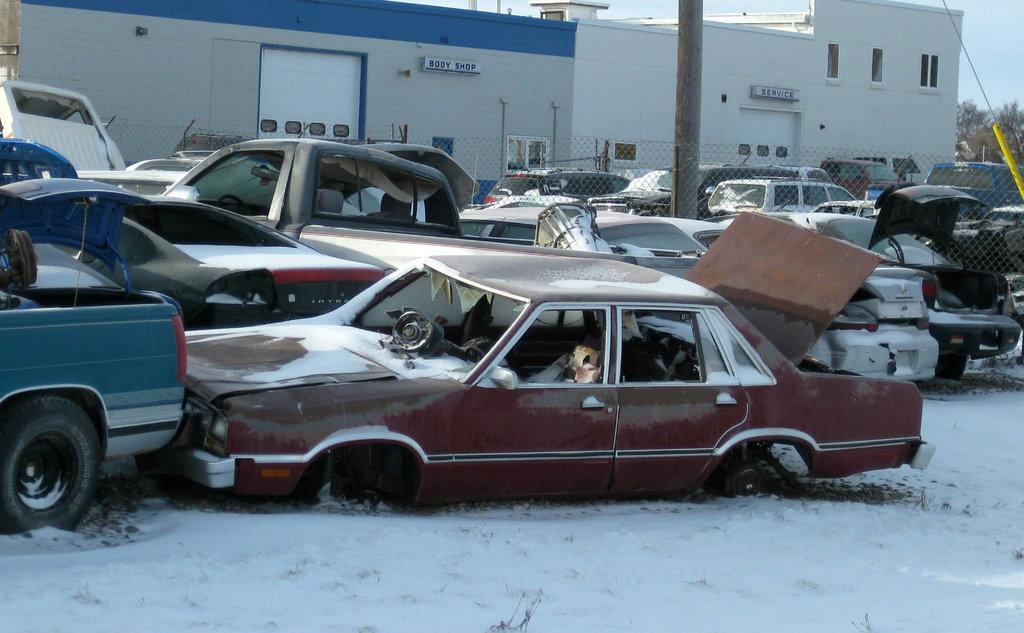What type of vehicles can be seen in the image? There are cars in the image. What is the weather condition in the image? There is snow in the image, indicating a cold and wintry scene. What type of barrier is present in the image? There is a fence in the image. What type of structures are visible in the image? There are buildings in the image. What architectural feature can be seen in the buildings? There are windows in the image. What type of natural vegetation is present in the image? There are trees in the image. What is visible in the background of the image? The sky is visible in the image. Can you tell me how many ships are docked near the buildings in the image? There are no ships present in the image; it features cars, snow, a fence, buildings, windows, trees, and a visible sky. What type of shock can be seen affecting the trees in the image? There is no shock affecting the trees in the image; they appear to be standing normally among the snow. 